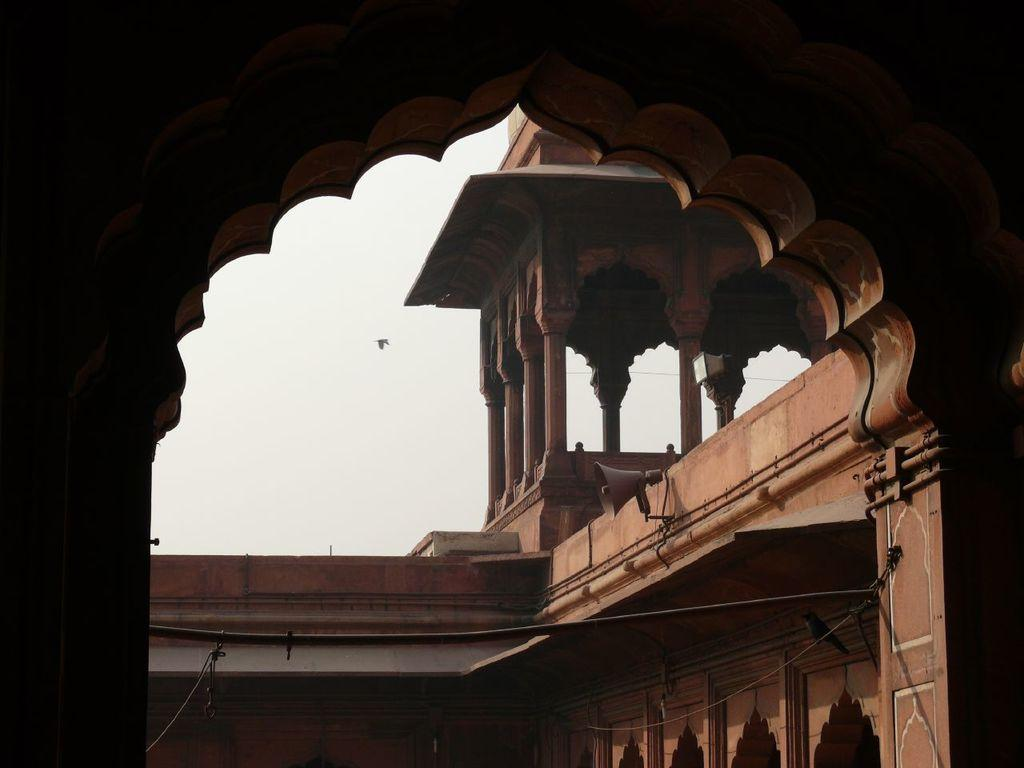What is the main structure in the foreground of the image? There is a fort in the foreground of the image. What can be seen in the background of the image? The sky is visible in the center of the image. What object is located on the right side of the image? There is a speaker on the right side of the image. Who is the partner of the person celebrating their birthday in the image? There is no indication of a birthday or a person celebrating in the image. How many seats are available for people to sit on in the image? There is no reference to seats or people sitting in the image. 